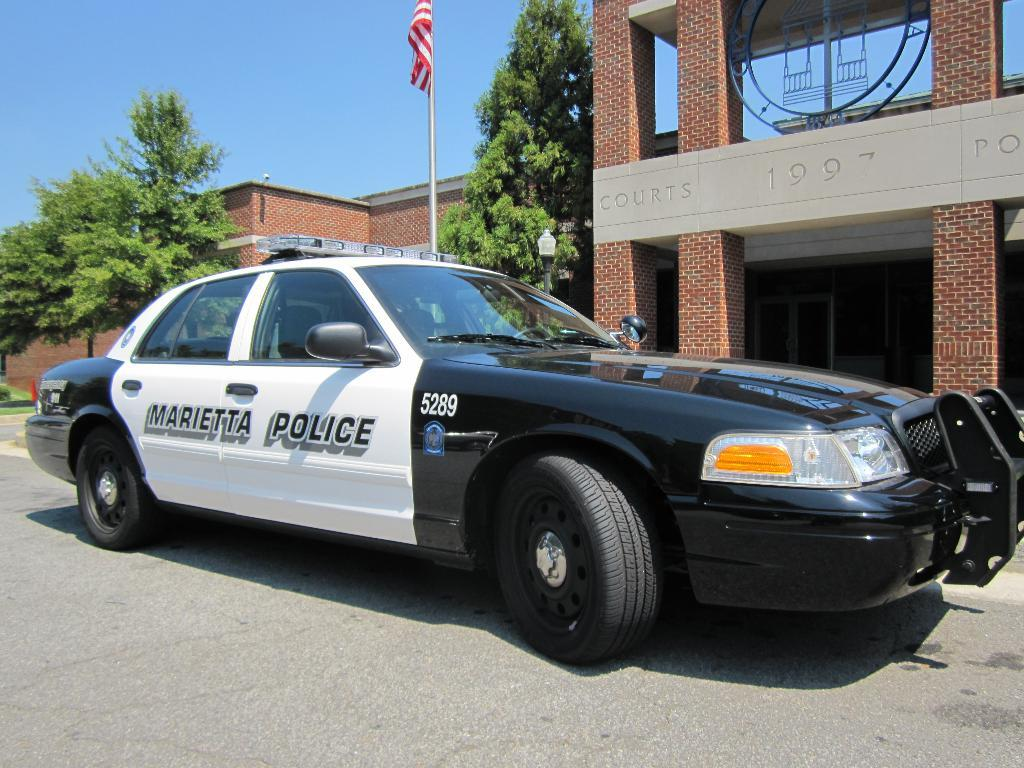<image>
Create a compact narrative representing the image presented. A marietta police vehicle infront of the court house. 